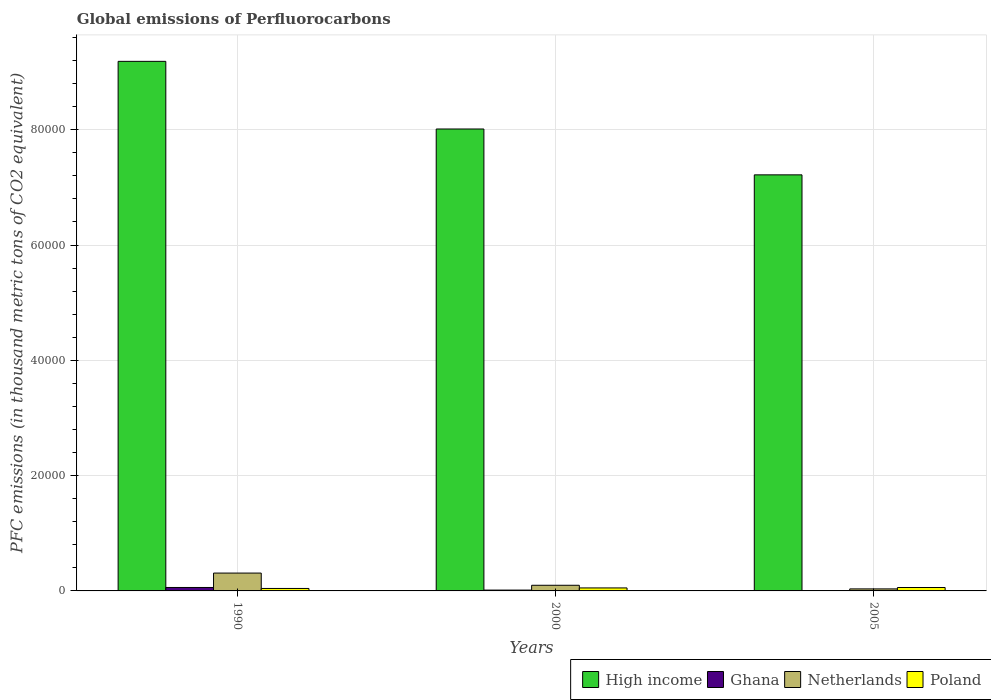How many different coloured bars are there?
Offer a very short reply. 4. Are the number of bars per tick equal to the number of legend labels?
Give a very brief answer. Yes. How many bars are there on the 1st tick from the left?
Provide a succinct answer. 4. How many bars are there on the 1st tick from the right?
Offer a terse response. 4. In how many cases, is the number of bars for a given year not equal to the number of legend labels?
Ensure brevity in your answer.  0. What is the global emissions of Perfluorocarbons in High income in 2000?
Offer a very short reply. 8.01e+04. Across all years, what is the maximum global emissions of Perfluorocarbons in Netherlands?
Ensure brevity in your answer.  3096.2. Across all years, what is the minimum global emissions of Perfluorocarbons in High income?
Offer a terse response. 7.22e+04. In which year was the global emissions of Perfluorocarbons in Poland maximum?
Your answer should be very brief. 2005. What is the total global emissions of Perfluorocarbons in Poland in the graph?
Provide a succinct answer. 1539.8. What is the difference between the global emissions of Perfluorocarbons in Netherlands in 1990 and that in 2000?
Keep it short and to the point. 2116.7. What is the difference between the global emissions of Perfluorocarbons in High income in 2000 and the global emissions of Perfluorocarbons in Ghana in 1990?
Your answer should be compact. 7.95e+04. What is the average global emissions of Perfluorocarbons in High income per year?
Your answer should be compact. 8.14e+04. In the year 2000, what is the difference between the global emissions of Perfluorocarbons in Ghana and global emissions of Perfluorocarbons in Poland?
Your answer should be very brief. -373.2. In how many years, is the global emissions of Perfluorocarbons in Netherlands greater than 44000 thousand metric tons?
Offer a very short reply. 0. What is the ratio of the global emissions of Perfluorocarbons in Ghana in 2000 to that in 2005?
Provide a short and direct response. 21.17. Is the difference between the global emissions of Perfluorocarbons in Ghana in 1990 and 2000 greater than the difference between the global emissions of Perfluorocarbons in Poland in 1990 and 2000?
Make the answer very short. Yes. What is the difference between the highest and the second highest global emissions of Perfluorocarbons in Netherlands?
Your answer should be very brief. 2116.7. What is the difference between the highest and the lowest global emissions of Perfluorocarbons in Poland?
Provide a succinct answer. 164.9. Is the sum of the global emissions of Perfluorocarbons in Poland in 1990 and 2000 greater than the maximum global emissions of Perfluorocarbons in High income across all years?
Ensure brevity in your answer.  No. What does the 2nd bar from the right in 1990 represents?
Make the answer very short. Netherlands. How many bars are there?
Your answer should be very brief. 12. Are all the bars in the graph horizontal?
Ensure brevity in your answer.  No. What is the difference between two consecutive major ticks on the Y-axis?
Ensure brevity in your answer.  2.00e+04. Are the values on the major ticks of Y-axis written in scientific E-notation?
Provide a succinct answer. No. Does the graph contain any zero values?
Make the answer very short. No. Does the graph contain grids?
Provide a short and direct response. Yes. Where does the legend appear in the graph?
Your answer should be compact. Bottom right. How are the legend labels stacked?
Provide a short and direct response. Horizontal. What is the title of the graph?
Make the answer very short. Global emissions of Perfluorocarbons. Does "Least developed countries" appear as one of the legend labels in the graph?
Make the answer very short. No. What is the label or title of the Y-axis?
Ensure brevity in your answer.  PFC emissions (in thousand metric tons of CO2 equivalent). What is the PFC emissions (in thousand metric tons of CO2 equivalent) of High income in 1990?
Ensure brevity in your answer.  9.19e+04. What is the PFC emissions (in thousand metric tons of CO2 equivalent) in Ghana in 1990?
Give a very brief answer. 596.2. What is the PFC emissions (in thousand metric tons of CO2 equivalent) of Netherlands in 1990?
Offer a terse response. 3096.2. What is the PFC emissions (in thousand metric tons of CO2 equivalent) in Poland in 1990?
Offer a very short reply. 427.8. What is the PFC emissions (in thousand metric tons of CO2 equivalent) in High income in 2000?
Your answer should be compact. 8.01e+04. What is the PFC emissions (in thousand metric tons of CO2 equivalent) of Ghana in 2000?
Make the answer very short. 146.1. What is the PFC emissions (in thousand metric tons of CO2 equivalent) of Netherlands in 2000?
Your response must be concise. 979.5. What is the PFC emissions (in thousand metric tons of CO2 equivalent) in Poland in 2000?
Ensure brevity in your answer.  519.3. What is the PFC emissions (in thousand metric tons of CO2 equivalent) in High income in 2005?
Your response must be concise. 7.22e+04. What is the PFC emissions (in thousand metric tons of CO2 equivalent) in Ghana in 2005?
Ensure brevity in your answer.  6.9. What is the PFC emissions (in thousand metric tons of CO2 equivalent) of Netherlands in 2005?
Make the answer very short. 351.4. What is the PFC emissions (in thousand metric tons of CO2 equivalent) in Poland in 2005?
Offer a terse response. 592.7. Across all years, what is the maximum PFC emissions (in thousand metric tons of CO2 equivalent) in High income?
Offer a very short reply. 9.19e+04. Across all years, what is the maximum PFC emissions (in thousand metric tons of CO2 equivalent) in Ghana?
Provide a succinct answer. 596.2. Across all years, what is the maximum PFC emissions (in thousand metric tons of CO2 equivalent) in Netherlands?
Give a very brief answer. 3096.2. Across all years, what is the maximum PFC emissions (in thousand metric tons of CO2 equivalent) in Poland?
Your answer should be very brief. 592.7. Across all years, what is the minimum PFC emissions (in thousand metric tons of CO2 equivalent) in High income?
Give a very brief answer. 7.22e+04. Across all years, what is the minimum PFC emissions (in thousand metric tons of CO2 equivalent) of Ghana?
Provide a short and direct response. 6.9. Across all years, what is the minimum PFC emissions (in thousand metric tons of CO2 equivalent) in Netherlands?
Give a very brief answer. 351.4. Across all years, what is the minimum PFC emissions (in thousand metric tons of CO2 equivalent) of Poland?
Offer a very short reply. 427.8. What is the total PFC emissions (in thousand metric tons of CO2 equivalent) of High income in the graph?
Keep it short and to the point. 2.44e+05. What is the total PFC emissions (in thousand metric tons of CO2 equivalent) in Ghana in the graph?
Provide a succinct answer. 749.2. What is the total PFC emissions (in thousand metric tons of CO2 equivalent) of Netherlands in the graph?
Ensure brevity in your answer.  4427.1. What is the total PFC emissions (in thousand metric tons of CO2 equivalent) of Poland in the graph?
Make the answer very short. 1539.8. What is the difference between the PFC emissions (in thousand metric tons of CO2 equivalent) in High income in 1990 and that in 2000?
Ensure brevity in your answer.  1.17e+04. What is the difference between the PFC emissions (in thousand metric tons of CO2 equivalent) in Ghana in 1990 and that in 2000?
Your answer should be compact. 450.1. What is the difference between the PFC emissions (in thousand metric tons of CO2 equivalent) in Netherlands in 1990 and that in 2000?
Make the answer very short. 2116.7. What is the difference between the PFC emissions (in thousand metric tons of CO2 equivalent) in Poland in 1990 and that in 2000?
Your answer should be compact. -91.5. What is the difference between the PFC emissions (in thousand metric tons of CO2 equivalent) in High income in 1990 and that in 2005?
Provide a succinct answer. 1.97e+04. What is the difference between the PFC emissions (in thousand metric tons of CO2 equivalent) in Ghana in 1990 and that in 2005?
Your response must be concise. 589.3. What is the difference between the PFC emissions (in thousand metric tons of CO2 equivalent) of Netherlands in 1990 and that in 2005?
Ensure brevity in your answer.  2744.8. What is the difference between the PFC emissions (in thousand metric tons of CO2 equivalent) of Poland in 1990 and that in 2005?
Ensure brevity in your answer.  -164.9. What is the difference between the PFC emissions (in thousand metric tons of CO2 equivalent) in High income in 2000 and that in 2005?
Provide a succinct answer. 7954.84. What is the difference between the PFC emissions (in thousand metric tons of CO2 equivalent) of Ghana in 2000 and that in 2005?
Your answer should be compact. 139.2. What is the difference between the PFC emissions (in thousand metric tons of CO2 equivalent) of Netherlands in 2000 and that in 2005?
Your answer should be very brief. 628.1. What is the difference between the PFC emissions (in thousand metric tons of CO2 equivalent) in Poland in 2000 and that in 2005?
Make the answer very short. -73.4. What is the difference between the PFC emissions (in thousand metric tons of CO2 equivalent) in High income in 1990 and the PFC emissions (in thousand metric tons of CO2 equivalent) in Ghana in 2000?
Make the answer very short. 9.17e+04. What is the difference between the PFC emissions (in thousand metric tons of CO2 equivalent) of High income in 1990 and the PFC emissions (in thousand metric tons of CO2 equivalent) of Netherlands in 2000?
Ensure brevity in your answer.  9.09e+04. What is the difference between the PFC emissions (in thousand metric tons of CO2 equivalent) of High income in 1990 and the PFC emissions (in thousand metric tons of CO2 equivalent) of Poland in 2000?
Provide a succinct answer. 9.13e+04. What is the difference between the PFC emissions (in thousand metric tons of CO2 equivalent) of Ghana in 1990 and the PFC emissions (in thousand metric tons of CO2 equivalent) of Netherlands in 2000?
Your answer should be compact. -383.3. What is the difference between the PFC emissions (in thousand metric tons of CO2 equivalent) of Ghana in 1990 and the PFC emissions (in thousand metric tons of CO2 equivalent) of Poland in 2000?
Provide a succinct answer. 76.9. What is the difference between the PFC emissions (in thousand metric tons of CO2 equivalent) in Netherlands in 1990 and the PFC emissions (in thousand metric tons of CO2 equivalent) in Poland in 2000?
Your response must be concise. 2576.9. What is the difference between the PFC emissions (in thousand metric tons of CO2 equivalent) in High income in 1990 and the PFC emissions (in thousand metric tons of CO2 equivalent) in Ghana in 2005?
Provide a short and direct response. 9.18e+04. What is the difference between the PFC emissions (in thousand metric tons of CO2 equivalent) of High income in 1990 and the PFC emissions (in thousand metric tons of CO2 equivalent) of Netherlands in 2005?
Offer a terse response. 9.15e+04. What is the difference between the PFC emissions (in thousand metric tons of CO2 equivalent) in High income in 1990 and the PFC emissions (in thousand metric tons of CO2 equivalent) in Poland in 2005?
Offer a terse response. 9.13e+04. What is the difference between the PFC emissions (in thousand metric tons of CO2 equivalent) in Ghana in 1990 and the PFC emissions (in thousand metric tons of CO2 equivalent) in Netherlands in 2005?
Your response must be concise. 244.8. What is the difference between the PFC emissions (in thousand metric tons of CO2 equivalent) in Netherlands in 1990 and the PFC emissions (in thousand metric tons of CO2 equivalent) in Poland in 2005?
Give a very brief answer. 2503.5. What is the difference between the PFC emissions (in thousand metric tons of CO2 equivalent) in High income in 2000 and the PFC emissions (in thousand metric tons of CO2 equivalent) in Ghana in 2005?
Your answer should be compact. 8.01e+04. What is the difference between the PFC emissions (in thousand metric tons of CO2 equivalent) in High income in 2000 and the PFC emissions (in thousand metric tons of CO2 equivalent) in Netherlands in 2005?
Your answer should be very brief. 7.98e+04. What is the difference between the PFC emissions (in thousand metric tons of CO2 equivalent) of High income in 2000 and the PFC emissions (in thousand metric tons of CO2 equivalent) of Poland in 2005?
Provide a succinct answer. 7.95e+04. What is the difference between the PFC emissions (in thousand metric tons of CO2 equivalent) of Ghana in 2000 and the PFC emissions (in thousand metric tons of CO2 equivalent) of Netherlands in 2005?
Keep it short and to the point. -205.3. What is the difference between the PFC emissions (in thousand metric tons of CO2 equivalent) of Ghana in 2000 and the PFC emissions (in thousand metric tons of CO2 equivalent) of Poland in 2005?
Your response must be concise. -446.6. What is the difference between the PFC emissions (in thousand metric tons of CO2 equivalent) in Netherlands in 2000 and the PFC emissions (in thousand metric tons of CO2 equivalent) in Poland in 2005?
Provide a short and direct response. 386.8. What is the average PFC emissions (in thousand metric tons of CO2 equivalent) of High income per year?
Your response must be concise. 8.14e+04. What is the average PFC emissions (in thousand metric tons of CO2 equivalent) of Ghana per year?
Give a very brief answer. 249.73. What is the average PFC emissions (in thousand metric tons of CO2 equivalent) of Netherlands per year?
Offer a very short reply. 1475.7. What is the average PFC emissions (in thousand metric tons of CO2 equivalent) in Poland per year?
Offer a terse response. 513.27. In the year 1990, what is the difference between the PFC emissions (in thousand metric tons of CO2 equivalent) of High income and PFC emissions (in thousand metric tons of CO2 equivalent) of Ghana?
Provide a succinct answer. 9.13e+04. In the year 1990, what is the difference between the PFC emissions (in thousand metric tons of CO2 equivalent) of High income and PFC emissions (in thousand metric tons of CO2 equivalent) of Netherlands?
Make the answer very short. 8.88e+04. In the year 1990, what is the difference between the PFC emissions (in thousand metric tons of CO2 equivalent) in High income and PFC emissions (in thousand metric tons of CO2 equivalent) in Poland?
Give a very brief answer. 9.14e+04. In the year 1990, what is the difference between the PFC emissions (in thousand metric tons of CO2 equivalent) in Ghana and PFC emissions (in thousand metric tons of CO2 equivalent) in Netherlands?
Offer a terse response. -2500. In the year 1990, what is the difference between the PFC emissions (in thousand metric tons of CO2 equivalent) of Ghana and PFC emissions (in thousand metric tons of CO2 equivalent) of Poland?
Ensure brevity in your answer.  168.4. In the year 1990, what is the difference between the PFC emissions (in thousand metric tons of CO2 equivalent) in Netherlands and PFC emissions (in thousand metric tons of CO2 equivalent) in Poland?
Offer a very short reply. 2668.4. In the year 2000, what is the difference between the PFC emissions (in thousand metric tons of CO2 equivalent) of High income and PFC emissions (in thousand metric tons of CO2 equivalent) of Ghana?
Give a very brief answer. 8.00e+04. In the year 2000, what is the difference between the PFC emissions (in thousand metric tons of CO2 equivalent) of High income and PFC emissions (in thousand metric tons of CO2 equivalent) of Netherlands?
Your answer should be very brief. 7.91e+04. In the year 2000, what is the difference between the PFC emissions (in thousand metric tons of CO2 equivalent) of High income and PFC emissions (in thousand metric tons of CO2 equivalent) of Poland?
Your answer should be compact. 7.96e+04. In the year 2000, what is the difference between the PFC emissions (in thousand metric tons of CO2 equivalent) in Ghana and PFC emissions (in thousand metric tons of CO2 equivalent) in Netherlands?
Provide a short and direct response. -833.4. In the year 2000, what is the difference between the PFC emissions (in thousand metric tons of CO2 equivalent) of Ghana and PFC emissions (in thousand metric tons of CO2 equivalent) of Poland?
Make the answer very short. -373.2. In the year 2000, what is the difference between the PFC emissions (in thousand metric tons of CO2 equivalent) of Netherlands and PFC emissions (in thousand metric tons of CO2 equivalent) of Poland?
Your answer should be very brief. 460.2. In the year 2005, what is the difference between the PFC emissions (in thousand metric tons of CO2 equivalent) of High income and PFC emissions (in thousand metric tons of CO2 equivalent) of Ghana?
Keep it short and to the point. 7.22e+04. In the year 2005, what is the difference between the PFC emissions (in thousand metric tons of CO2 equivalent) in High income and PFC emissions (in thousand metric tons of CO2 equivalent) in Netherlands?
Provide a succinct answer. 7.18e+04. In the year 2005, what is the difference between the PFC emissions (in thousand metric tons of CO2 equivalent) of High income and PFC emissions (in thousand metric tons of CO2 equivalent) of Poland?
Offer a very short reply. 7.16e+04. In the year 2005, what is the difference between the PFC emissions (in thousand metric tons of CO2 equivalent) of Ghana and PFC emissions (in thousand metric tons of CO2 equivalent) of Netherlands?
Provide a short and direct response. -344.5. In the year 2005, what is the difference between the PFC emissions (in thousand metric tons of CO2 equivalent) of Ghana and PFC emissions (in thousand metric tons of CO2 equivalent) of Poland?
Offer a very short reply. -585.8. In the year 2005, what is the difference between the PFC emissions (in thousand metric tons of CO2 equivalent) of Netherlands and PFC emissions (in thousand metric tons of CO2 equivalent) of Poland?
Provide a short and direct response. -241.3. What is the ratio of the PFC emissions (in thousand metric tons of CO2 equivalent) in High income in 1990 to that in 2000?
Your response must be concise. 1.15. What is the ratio of the PFC emissions (in thousand metric tons of CO2 equivalent) in Ghana in 1990 to that in 2000?
Offer a terse response. 4.08. What is the ratio of the PFC emissions (in thousand metric tons of CO2 equivalent) in Netherlands in 1990 to that in 2000?
Give a very brief answer. 3.16. What is the ratio of the PFC emissions (in thousand metric tons of CO2 equivalent) in Poland in 1990 to that in 2000?
Offer a terse response. 0.82. What is the ratio of the PFC emissions (in thousand metric tons of CO2 equivalent) of High income in 1990 to that in 2005?
Ensure brevity in your answer.  1.27. What is the ratio of the PFC emissions (in thousand metric tons of CO2 equivalent) of Ghana in 1990 to that in 2005?
Provide a short and direct response. 86.41. What is the ratio of the PFC emissions (in thousand metric tons of CO2 equivalent) of Netherlands in 1990 to that in 2005?
Your answer should be compact. 8.81. What is the ratio of the PFC emissions (in thousand metric tons of CO2 equivalent) in Poland in 1990 to that in 2005?
Keep it short and to the point. 0.72. What is the ratio of the PFC emissions (in thousand metric tons of CO2 equivalent) in High income in 2000 to that in 2005?
Keep it short and to the point. 1.11. What is the ratio of the PFC emissions (in thousand metric tons of CO2 equivalent) in Ghana in 2000 to that in 2005?
Make the answer very short. 21.17. What is the ratio of the PFC emissions (in thousand metric tons of CO2 equivalent) in Netherlands in 2000 to that in 2005?
Offer a terse response. 2.79. What is the ratio of the PFC emissions (in thousand metric tons of CO2 equivalent) in Poland in 2000 to that in 2005?
Your response must be concise. 0.88. What is the difference between the highest and the second highest PFC emissions (in thousand metric tons of CO2 equivalent) in High income?
Keep it short and to the point. 1.17e+04. What is the difference between the highest and the second highest PFC emissions (in thousand metric tons of CO2 equivalent) in Ghana?
Give a very brief answer. 450.1. What is the difference between the highest and the second highest PFC emissions (in thousand metric tons of CO2 equivalent) of Netherlands?
Offer a very short reply. 2116.7. What is the difference between the highest and the second highest PFC emissions (in thousand metric tons of CO2 equivalent) in Poland?
Keep it short and to the point. 73.4. What is the difference between the highest and the lowest PFC emissions (in thousand metric tons of CO2 equivalent) of High income?
Offer a very short reply. 1.97e+04. What is the difference between the highest and the lowest PFC emissions (in thousand metric tons of CO2 equivalent) in Ghana?
Provide a short and direct response. 589.3. What is the difference between the highest and the lowest PFC emissions (in thousand metric tons of CO2 equivalent) of Netherlands?
Make the answer very short. 2744.8. What is the difference between the highest and the lowest PFC emissions (in thousand metric tons of CO2 equivalent) of Poland?
Your response must be concise. 164.9. 